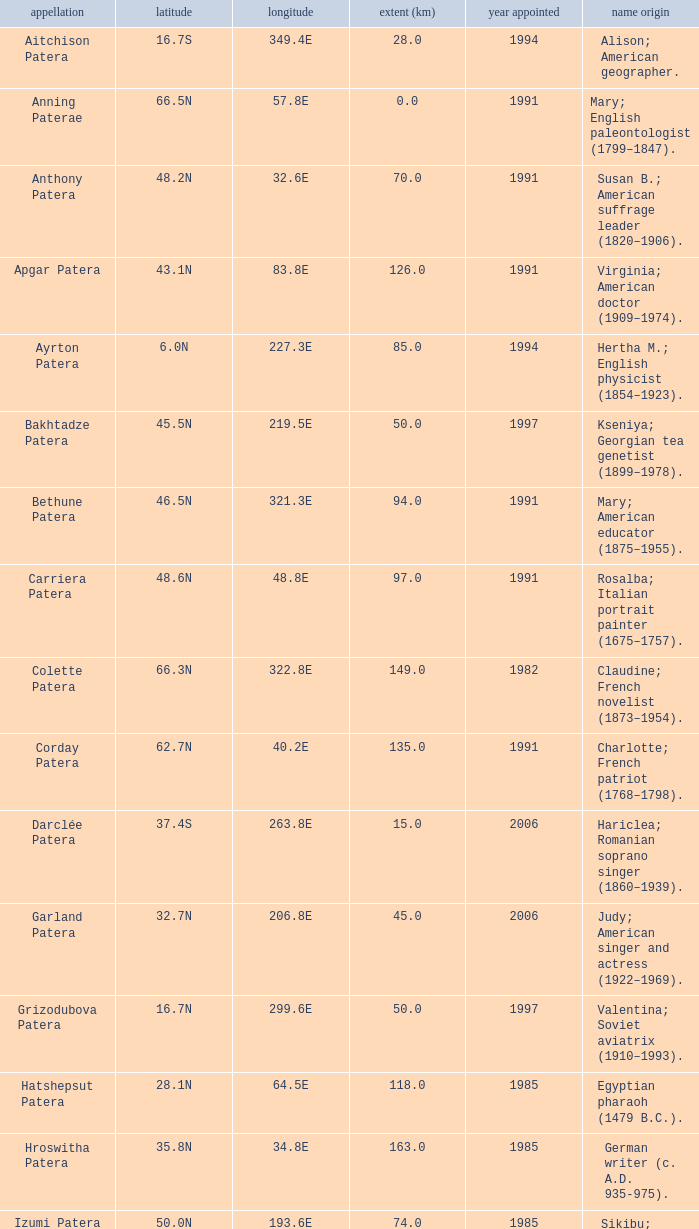In what year was the feature at a 33.3S latitude named?  2000.0. 